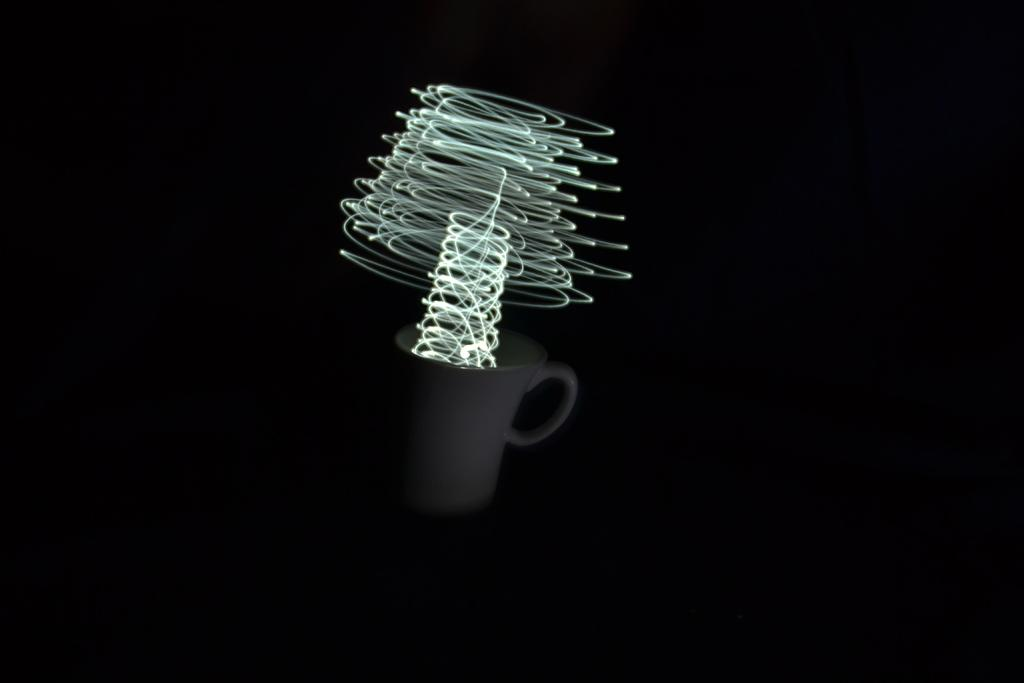What object can be seen in the picture? There is a coffee mug in the picture. What can be seen illuminating the scene? There are lights visible in the picture. How would you describe the overall appearance of the background? The backdrop of the image is dark. What type of knot is being tied in the picture? There is no knot present in the image; it features a coffee mug and lights. What is your opinion on the coffee mug in the picture? As an AI, I do not have personal opinions, but the coffee mug appears to be the main subject in the image. 